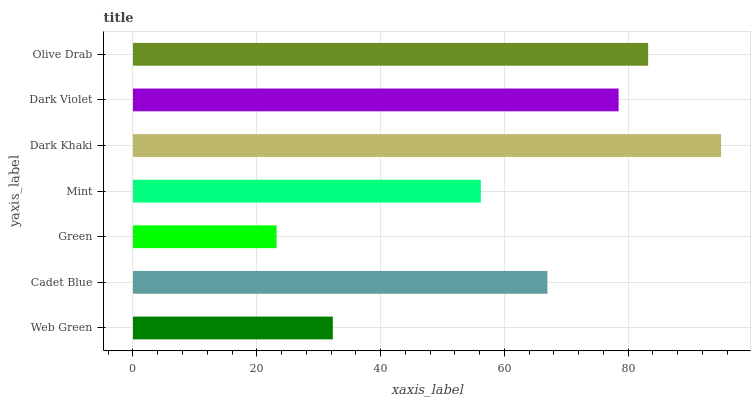Is Green the minimum?
Answer yes or no. Yes. Is Dark Khaki the maximum?
Answer yes or no. Yes. Is Cadet Blue the minimum?
Answer yes or no. No. Is Cadet Blue the maximum?
Answer yes or no. No. Is Cadet Blue greater than Web Green?
Answer yes or no. Yes. Is Web Green less than Cadet Blue?
Answer yes or no. Yes. Is Web Green greater than Cadet Blue?
Answer yes or no. No. Is Cadet Blue less than Web Green?
Answer yes or no. No. Is Cadet Blue the high median?
Answer yes or no. Yes. Is Cadet Blue the low median?
Answer yes or no. Yes. Is Web Green the high median?
Answer yes or no. No. Is Dark Violet the low median?
Answer yes or no. No. 